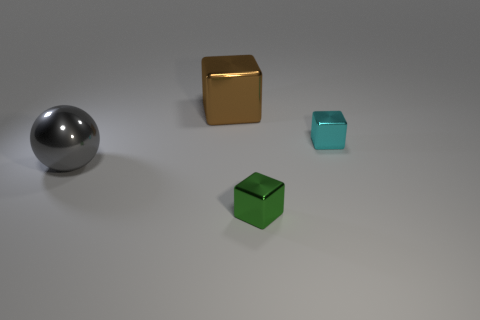Is the size of the brown thing the same as the green thing?
Offer a very short reply. No. There is a block that is in front of the large gray sphere; is it the same color as the large metallic sphere?
Ensure brevity in your answer.  No. Are there any small cyan metal blocks on the right side of the small object behind the gray shiny sphere?
Your answer should be very brief. No. What is the material of the thing that is to the right of the big gray thing and in front of the small cyan cube?
Offer a very short reply. Metal. What shape is the small green object that is the same material as the cyan object?
Your response must be concise. Cube. Is there anything else that has the same shape as the tiny cyan metallic thing?
Your answer should be very brief. Yes. Is the thing that is in front of the large gray sphere made of the same material as the ball?
Keep it short and to the point. Yes. There is a tiny object left of the tiny cyan metal cube; what is its material?
Offer a very short reply. Metal. There is a cube left of the metallic block that is in front of the tiny cyan shiny block; how big is it?
Your answer should be compact. Large. How many brown cubes have the same size as the green metal thing?
Provide a succinct answer. 0. 